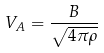<formula> <loc_0><loc_0><loc_500><loc_500>V _ { A } = \frac { B } { \sqrt { 4 \pi \rho } }</formula> 